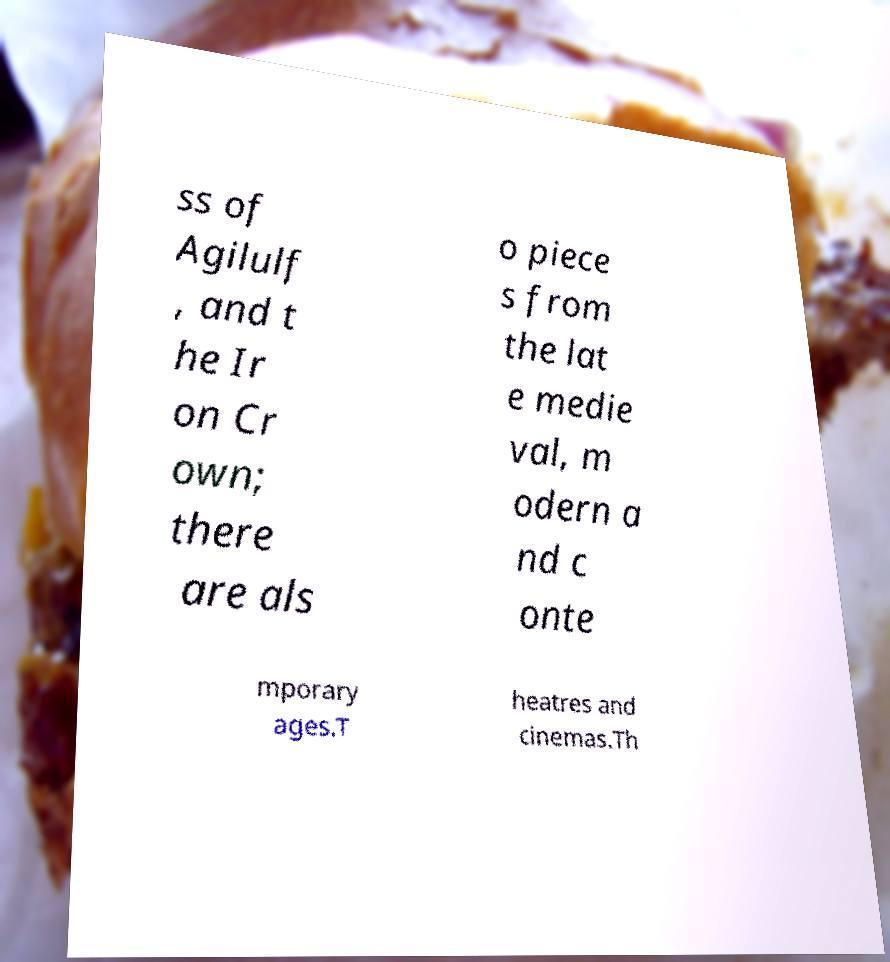Can you read and provide the text displayed in the image?This photo seems to have some interesting text. Can you extract and type it out for me? ss of Agilulf , and t he Ir on Cr own; there are als o piece s from the lat e medie val, m odern a nd c onte mporary ages.T heatres and cinemas.Th 